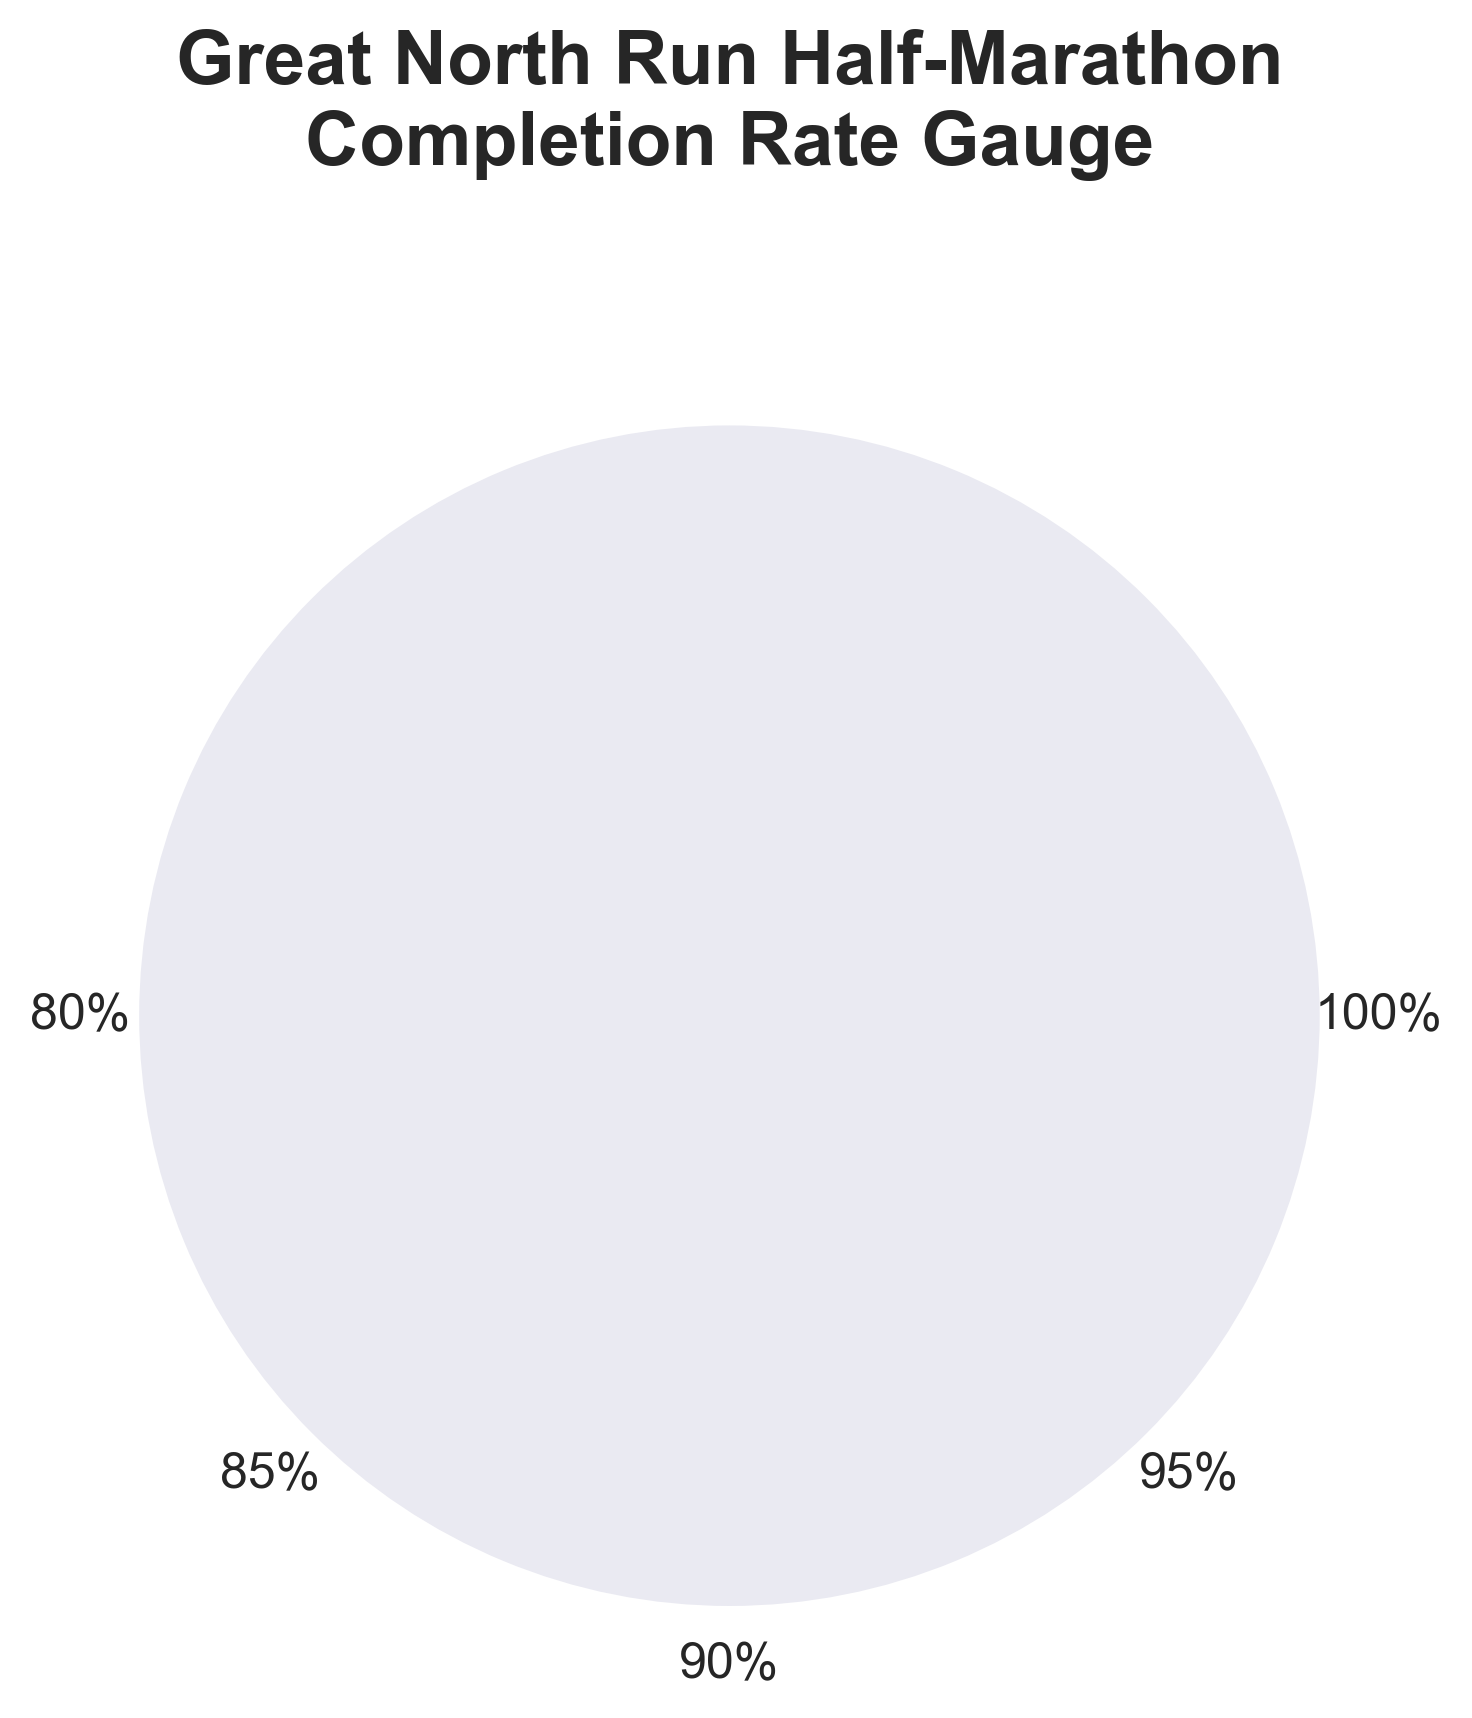What is the title of the chart? The title of the chart is displayed prominently at the top and reads: 'Great North Run Half-Marathon\nCompletion Rate Gauge'.
Answer: Great North Run Half-Marathon Completion Rate Gauge What is the average completion rate displayed on the chart? The average completion rate is shown as a large text in the center of the gauge and labeled as: 'Average Completion Rate'.
Answer: 92.7% How many percentage intervals are indicated along the scale? The percentage intervals are indicated by the scale labels around the arc. These are labeled as 80%, 85%, 90%, 95%, and 100%.
Answer: Five Which color is used to represent the value arc on the gauge? The value arc which represents the average completion rate is colored in crimson with a dark red edge.
Answer: Crimson What does the light grey arc on the gauge represent? The light grey arc represents the background of the gauge, defining the entire range from 80% to 100%.
Answer: Background range How does the average completion rate compare to the '100%' mark on the gauge? The average completion rate is shown to be significantly less than the '100%' mark, as the crimson value arc does not reach up to this point.
Answer: Less What would be the angle in degrees for the '85%' mark on the gauge? The gauge spans from 180 degrees to 360 degrees for the range 80% to 100%. The '85%' mark lies 25% of the total arc distance from the start (180 degrees). Thus, it is at 180 + 25% * (360 - 180) = 225 degrees.
Answer: 225 degrees Given that the average completion rate is 92.7%, what is the angle for this value on the gauge? The start angle is 180 degrees and end angle is 360 degrees. The rate of 92.7% relative to the range (80%-100%) can be interpolated as follows: 180 + ((92.7 - 80) / 20) * (360 - 180) = 223.65 degrees.
Answer: Around 223.65 degrees If we include the virtual event year (assuming a hypothetical 0% completion rate), how would the new average look? The current sum of completion rates excluding 2020 is 834.3% over 9 years, and if adding a 0% for 2020 then sum becomes 834.3%. The new average is 834.3 / 10.
Answer: 83.43% 